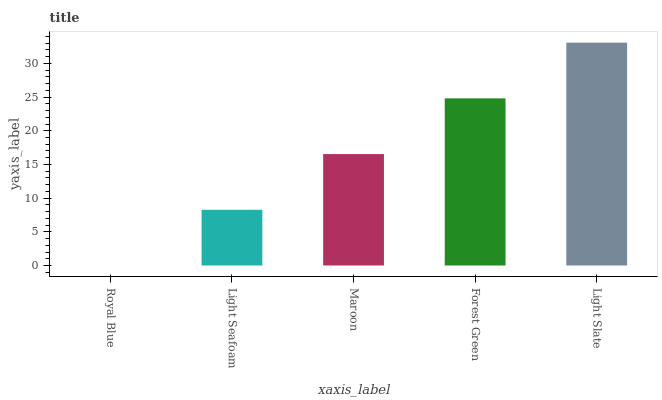Is Royal Blue the minimum?
Answer yes or no. Yes. Is Light Slate the maximum?
Answer yes or no. Yes. Is Light Seafoam the minimum?
Answer yes or no. No. Is Light Seafoam the maximum?
Answer yes or no. No. Is Light Seafoam greater than Royal Blue?
Answer yes or no. Yes. Is Royal Blue less than Light Seafoam?
Answer yes or no. Yes. Is Royal Blue greater than Light Seafoam?
Answer yes or no. No. Is Light Seafoam less than Royal Blue?
Answer yes or no. No. Is Maroon the high median?
Answer yes or no. Yes. Is Maroon the low median?
Answer yes or no. Yes. Is Light Slate the high median?
Answer yes or no. No. Is Royal Blue the low median?
Answer yes or no. No. 